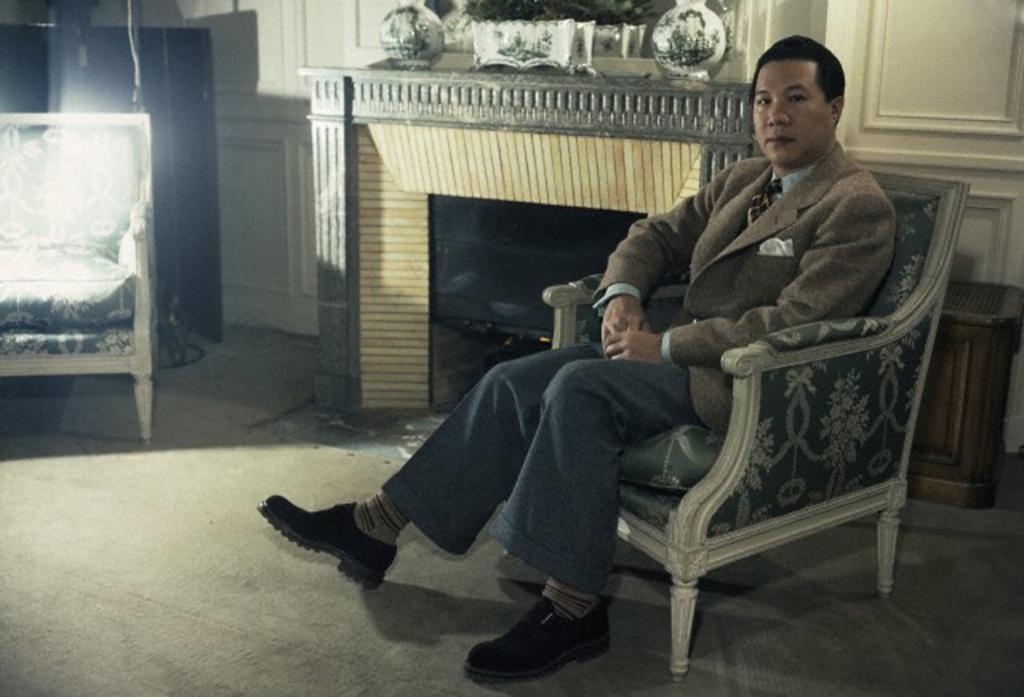Could you give a brief overview of what you see in this image? In this image the man is sitting on the chair at the back side we can see a building. 